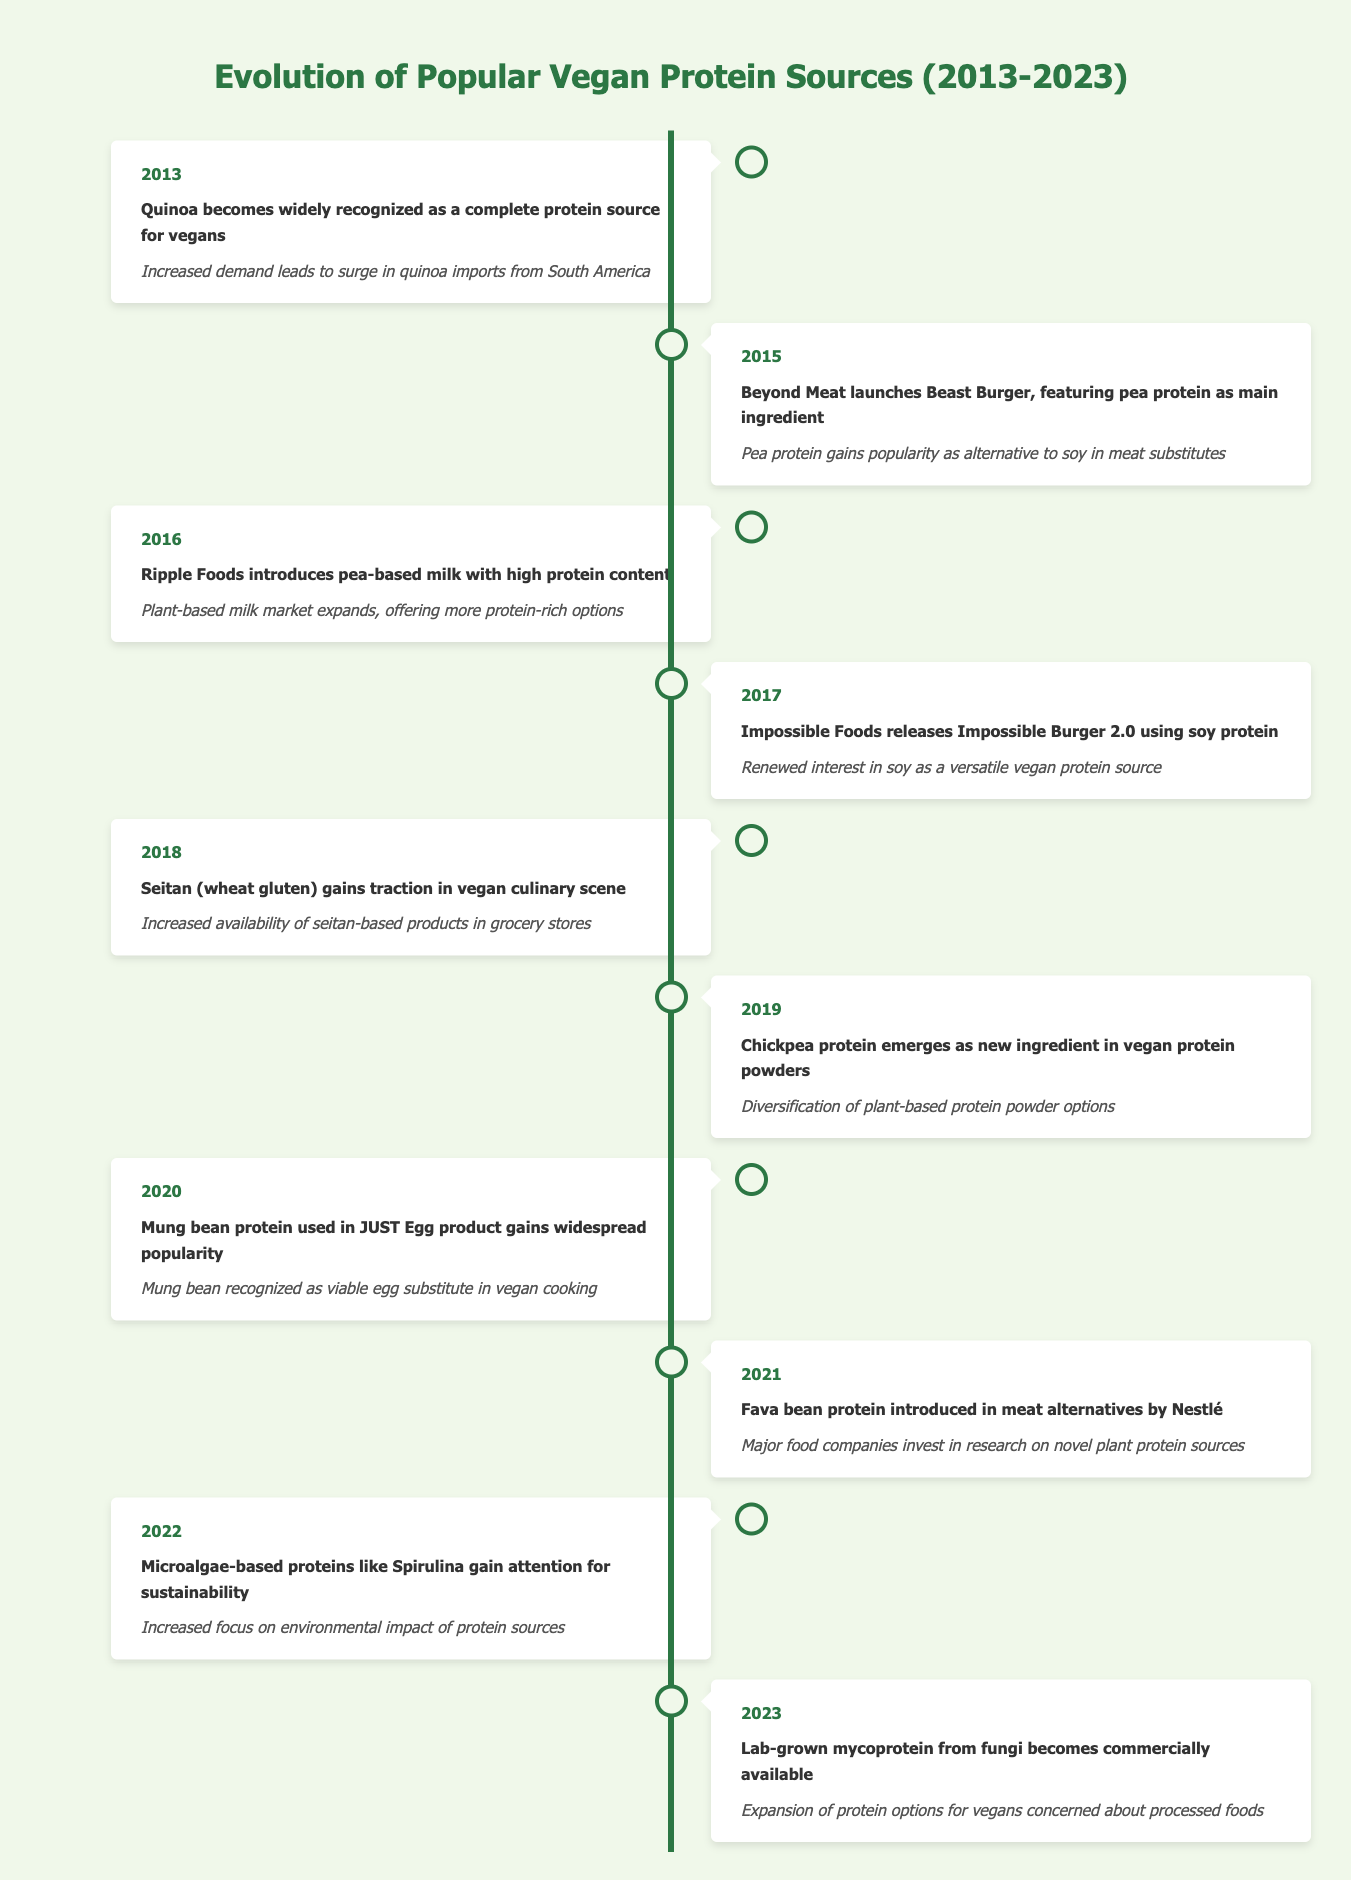What year did quinoa become recognized as a complete protein source for vegans? The table indicates that quinoa was recognized in 2013, which is specified in the year column corresponding to the event about quinoa.
Answer: 2013 In which year was pea protein popularized as an alternative to soy? The event that mentions pea protein gaining popularity is in 2015, when Beyond Meat launched the Beast Burger featuring pea protein.
Answer: 2015 What is the impact of the introduction of mung bean protein in 2020? The table states that mung bean protein was used in the JUST Egg product, which led to its recognition as a viable egg substitute in vegan cooking.
Answer: Mung bean recognized as a viable egg substitute in vegan cooking Which protein source gained attention for sustainability in 2022? The event listed for 2022 describes microalgae-based proteins, such as Spirulina, gaining attention specifically for sustainability.
Answer: Microalgae-based proteins like Spirulina How many years passed between the introduction of pea-based milk and chickpea protein in protein powders? Pea-based milk was introduced in 2016 and chickpea protein emerged as a new ingredient in 2019. The difference in years is 2019 - 2016 = 3 years.
Answer: 3 years Is the Impossible Burger made with soy protein? The data shows that the Impossible Burger 2.0 released in 2017 specifically mentions using soy protein, confirming this as a fact.
Answer: Yes Which protein sources were introduced in even-numbered years from 2016 to 2022? The even-numbered years from 2016 to 2022 include 2016 (pea-based milk), 2018 (seitan), and 2022 (microalgae-based proteins). Thus, the identified sources are all these three.
Answer: Pea-based milk, seitan, and microalgae-based proteins How many different plant-based protein sources were commercially available by 2023, considering that lab-grown mycoprotein was introduced that year? By referencing the timeline, we see mentions of quinoa, pea protein, soy protein, seitan, chickpea protein, mung bean, fava bean, microalgae-based proteins, and lab-grown mycoprotein. This gives a total of 9 unique sources by 2023.
Answer: 9 What was the trend in vegan protein sources from 2013 to 2023 based on the table? The timeline shows a diversification of protein sources, beginning with quinoa's recognition, followed by various introductions such as pea protein, mung bean, soc, and culminating with lab-grown options in 2023, indicating an evolution towards more varied and innovative protein sources.
Answer: Diversification and innovation in protein sources 